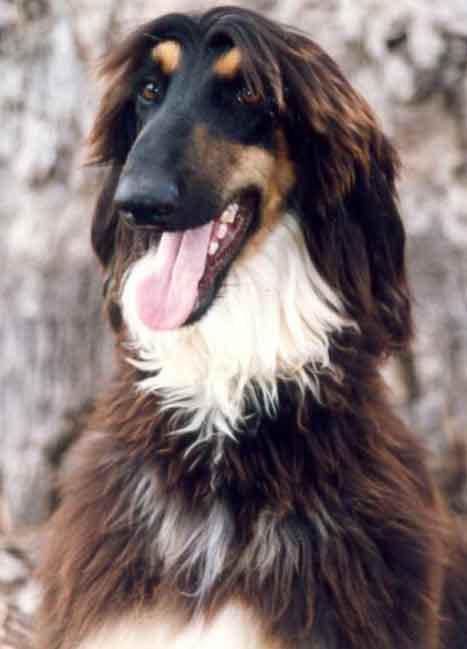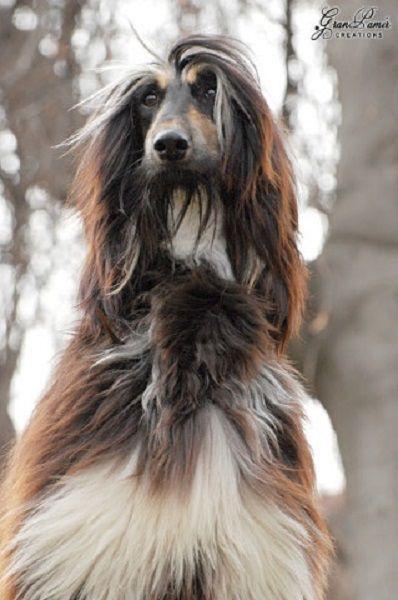The first image is the image on the left, the second image is the image on the right. Considering the images on both sides, is "One image features an afghan hound with long gray hair on its head that looks like a woman's wig, and the other image features an afghan hound with a very different look." valid? Answer yes or no. No. The first image is the image on the left, the second image is the image on the right. Analyze the images presented: Is the assertion "The dog in the image in the left has its mouth open." valid? Answer yes or no. Yes. 